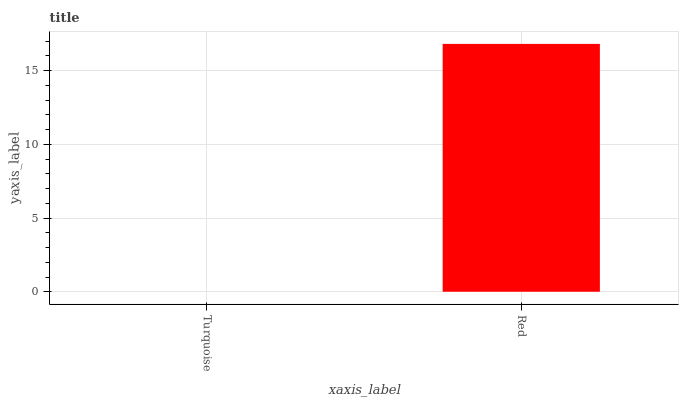Is Turquoise the minimum?
Answer yes or no. Yes. Is Red the maximum?
Answer yes or no. Yes. Is Red the minimum?
Answer yes or no. No. Is Red greater than Turquoise?
Answer yes or no. Yes. Is Turquoise less than Red?
Answer yes or no. Yes. Is Turquoise greater than Red?
Answer yes or no. No. Is Red less than Turquoise?
Answer yes or no. No. Is Red the high median?
Answer yes or no. Yes. Is Turquoise the low median?
Answer yes or no. Yes. Is Turquoise the high median?
Answer yes or no. No. Is Red the low median?
Answer yes or no. No. 